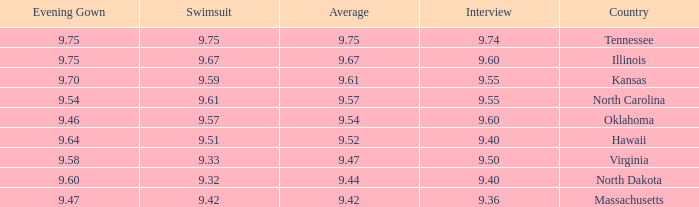Which country had an interview score of 9.40 and average of 9.44? North Dakota. 